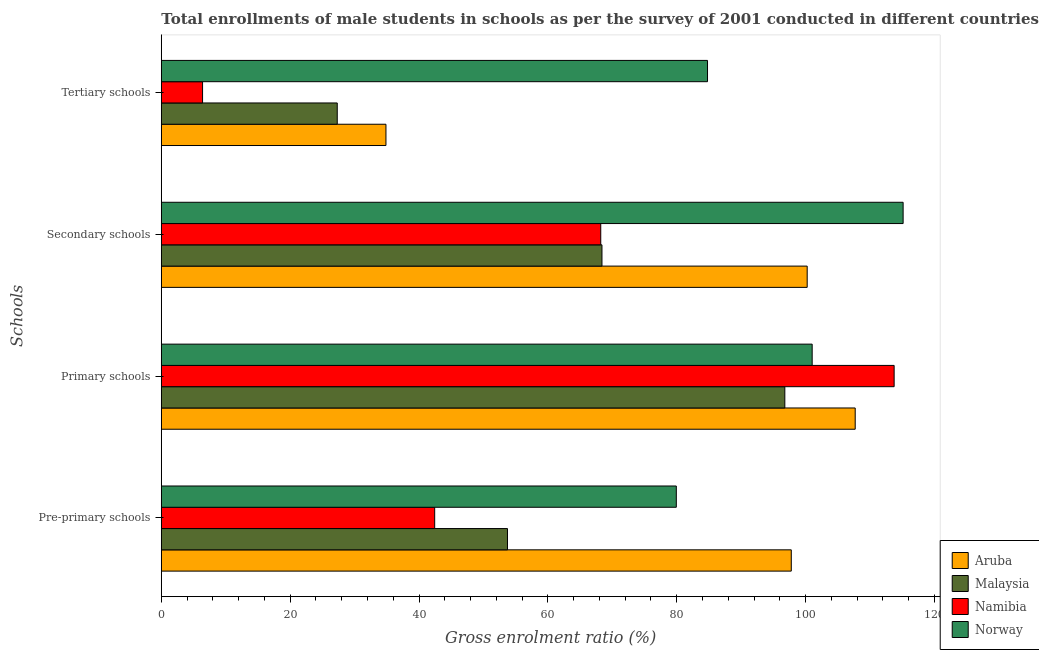Are the number of bars per tick equal to the number of legend labels?
Give a very brief answer. Yes. Are the number of bars on each tick of the Y-axis equal?
Provide a succinct answer. Yes. How many bars are there on the 2nd tick from the bottom?
Your answer should be compact. 4. What is the label of the 1st group of bars from the top?
Provide a short and direct response. Tertiary schools. What is the gross enrolment ratio(male) in pre-primary schools in Malaysia?
Your answer should be compact. 53.73. Across all countries, what is the maximum gross enrolment ratio(male) in pre-primary schools?
Your answer should be compact. 97.77. Across all countries, what is the minimum gross enrolment ratio(male) in primary schools?
Keep it short and to the point. 96.77. In which country was the gross enrolment ratio(male) in tertiary schools maximum?
Give a very brief answer. Norway. In which country was the gross enrolment ratio(male) in tertiary schools minimum?
Offer a terse response. Namibia. What is the total gross enrolment ratio(male) in tertiary schools in the graph?
Ensure brevity in your answer.  153.35. What is the difference between the gross enrolment ratio(male) in secondary schools in Norway and that in Malaysia?
Your answer should be very brief. 46.74. What is the difference between the gross enrolment ratio(male) in secondary schools in Aruba and the gross enrolment ratio(male) in tertiary schools in Norway?
Make the answer very short. 15.47. What is the average gross enrolment ratio(male) in tertiary schools per country?
Make the answer very short. 38.34. What is the difference between the gross enrolment ratio(male) in tertiary schools and gross enrolment ratio(male) in primary schools in Norway?
Make the answer very short. -16.24. In how many countries, is the gross enrolment ratio(male) in pre-primary schools greater than 52 %?
Ensure brevity in your answer.  3. What is the ratio of the gross enrolment ratio(male) in pre-primary schools in Namibia to that in Malaysia?
Provide a succinct answer. 0.79. Is the gross enrolment ratio(male) in primary schools in Malaysia less than that in Norway?
Offer a terse response. Yes. What is the difference between the highest and the second highest gross enrolment ratio(male) in pre-primary schools?
Give a very brief answer. 17.84. What is the difference between the highest and the lowest gross enrolment ratio(male) in primary schools?
Make the answer very short. 16.97. Is it the case that in every country, the sum of the gross enrolment ratio(male) in secondary schools and gross enrolment ratio(male) in tertiary schools is greater than the sum of gross enrolment ratio(male) in primary schools and gross enrolment ratio(male) in pre-primary schools?
Ensure brevity in your answer.  No. What does the 2nd bar from the top in Pre-primary schools represents?
Provide a short and direct response. Namibia. What does the 2nd bar from the bottom in Secondary schools represents?
Provide a short and direct response. Malaysia. How many bars are there?
Offer a very short reply. 16. Are all the bars in the graph horizontal?
Your answer should be compact. Yes. How many countries are there in the graph?
Provide a succinct answer. 4. Are the values on the major ticks of X-axis written in scientific E-notation?
Keep it short and to the point. No. Does the graph contain grids?
Your answer should be very brief. No. How are the legend labels stacked?
Offer a terse response. Vertical. What is the title of the graph?
Offer a terse response. Total enrollments of male students in schools as per the survey of 2001 conducted in different countries. What is the label or title of the X-axis?
Offer a terse response. Gross enrolment ratio (%). What is the label or title of the Y-axis?
Offer a very short reply. Schools. What is the Gross enrolment ratio (%) of Aruba in Pre-primary schools?
Make the answer very short. 97.77. What is the Gross enrolment ratio (%) of Malaysia in Pre-primary schools?
Your answer should be very brief. 53.73. What is the Gross enrolment ratio (%) in Namibia in Pre-primary schools?
Your response must be concise. 42.43. What is the Gross enrolment ratio (%) of Norway in Pre-primary schools?
Provide a succinct answer. 79.93. What is the Gross enrolment ratio (%) in Aruba in Primary schools?
Offer a terse response. 107.7. What is the Gross enrolment ratio (%) of Malaysia in Primary schools?
Offer a very short reply. 96.77. What is the Gross enrolment ratio (%) in Namibia in Primary schools?
Your answer should be very brief. 113.74. What is the Gross enrolment ratio (%) of Norway in Primary schools?
Offer a terse response. 101.02. What is the Gross enrolment ratio (%) in Aruba in Secondary schools?
Make the answer very short. 100.24. What is the Gross enrolment ratio (%) of Malaysia in Secondary schools?
Offer a terse response. 68.39. What is the Gross enrolment ratio (%) in Namibia in Secondary schools?
Keep it short and to the point. 68.2. What is the Gross enrolment ratio (%) of Norway in Secondary schools?
Make the answer very short. 115.13. What is the Gross enrolment ratio (%) in Aruba in Tertiary schools?
Provide a succinct answer. 34.87. What is the Gross enrolment ratio (%) in Malaysia in Tertiary schools?
Keep it short and to the point. 27.31. What is the Gross enrolment ratio (%) in Namibia in Tertiary schools?
Provide a short and direct response. 6.4. What is the Gross enrolment ratio (%) in Norway in Tertiary schools?
Provide a succinct answer. 84.77. Across all Schools, what is the maximum Gross enrolment ratio (%) in Aruba?
Make the answer very short. 107.7. Across all Schools, what is the maximum Gross enrolment ratio (%) of Malaysia?
Keep it short and to the point. 96.77. Across all Schools, what is the maximum Gross enrolment ratio (%) in Namibia?
Keep it short and to the point. 113.74. Across all Schools, what is the maximum Gross enrolment ratio (%) of Norway?
Your answer should be very brief. 115.13. Across all Schools, what is the minimum Gross enrolment ratio (%) in Aruba?
Give a very brief answer. 34.87. Across all Schools, what is the minimum Gross enrolment ratio (%) of Malaysia?
Provide a succinct answer. 27.31. Across all Schools, what is the minimum Gross enrolment ratio (%) of Namibia?
Your answer should be very brief. 6.4. Across all Schools, what is the minimum Gross enrolment ratio (%) in Norway?
Offer a terse response. 79.93. What is the total Gross enrolment ratio (%) of Aruba in the graph?
Offer a terse response. 340.58. What is the total Gross enrolment ratio (%) of Malaysia in the graph?
Make the answer very short. 246.2. What is the total Gross enrolment ratio (%) in Namibia in the graph?
Your answer should be compact. 230.77. What is the total Gross enrolment ratio (%) of Norway in the graph?
Provide a succinct answer. 380.85. What is the difference between the Gross enrolment ratio (%) in Aruba in Pre-primary schools and that in Primary schools?
Keep it short and to the point. -9.92. What is the difference between the Gross enrolment ratio (%) in Malaysia in Pre-primary schools and that in Primary schools?
Provide a short and direct response. -43.04. What is the difference between the Gross enrolment ratio (%) of Namibia in Pre-primary schools and that in Primary schools?
Ensure brevity in your answer.  -71.31. What is the difference between the Gross enrolment ratio (%) of Norway in Pre-primary schools and that in Primary schools?
Make the answer very short. -21.09. What is the difference between the Gross enrolment ratio (%) in Aruba in Pre-primary schools and that in Secondary schools?
Offer a terse response. -2.47. What is the difference between the Gross enrolment ratio (%) of Malaysia in Pre-primary schools and that in Secondary schools?
Your answer should be very brief. -14.66. What is the difference between the Gross enrolment ratio (%) in Namibia in Pre-primary schools and that in Secondary schools?
Offer a very short reply. -25.77. What is the difference between the Gross enrolment ratio (%) of Norway in Pre-primary schools and that in Secondary schools?
Give a very brief answer. -35.2. What is the difference between the Gross enrolment ratio (%) in Aruba in Pre-primary schools and that in Tertiary schools?
Keep it short and to the point. 62.91. What is the difference between the Gross enrolment ratio (%) in Malaysia in Pre-primary schools and that in Tertiary schools?
Keep it short and to the point. 26.42. What is the difference between the Gross enrolment ratio (%) in Namibia in Pre-primary schools and that in Tertiary schools?
Your answer should be compact. 36.03. What is the difference between the Gross enrolment ratio (%) in Norway in Pre-primary schools and that in Tertiary schools?
Offer a terse response. -4.84. What is the difference between the Gross enrolment ratio (%) of Aruba in Primary schools and that in Secondary schools?
Give a very brief answer. 7.45. What is the difference between the Gross enrolment ratio (%) of Malaysia in Primary schools and that in Secondary schools?
Your answer should be very brief. 28.38. What is the difference between the Gross enrolment ratio (%) of Namibia in Primary schools and that in Secondary schools?
Keep it short and to the point. 45.53. What is the difference between the Gross enrolment ratio (%) in Norway in Primary schools and that in Secondary schools?
Your answer should be compact. -14.12. What is the difference between the Gross enrolment ratio (%) of Aruba in Primary schools and that in Tertiary schools?
Keep it short and to the point. 72.83. What is the difference between the Gross enrolment ratio (%) in Malaysia in Primary schools and that in Tertiary schools?
Provide a succinct answer. 69.47. What is the difference between the Gross enrolment ratio (%) of Namibia in Primary schools and that in Tertiary schools?
Provide a short and direct response. 107.34. What is the difference between the Gross enrolment ratio (%) in Norway in Primary schools and that in Tertiary schools?
Provide a succinct answer. 16.24. What is the difference between the Gross enrolment ratio (%) of Aruba in Secondary schools and that in Tertiary schools?
Offer a terse response. 65.38. What is the difference between the Gross enrolment ratio (%) in Malaysia in Secondary schools and that in Tertiary schools?
Provide a short and direct response. 41.09. What is the difference between the Gross enrolment ratio (%) in Namibia in Secondary schools and that in Tertiary schools?
Give a very brief answer. 61.8. What is the difference between the Gross enrolment ratio (%) in Norway in Secondary schools and that in Tertiary schools?
Your response must be concise. 30.36. What is the difference between the Gross enrolment ratio (%) of Aruba in Pre-primary schools and the Gross enrolment ratio (%) of Malaysia in Primary schools?
Provide a succinct answer. 1. What is the difference between the Gross enrolment ratio (%) in Aruba in Pre-primary schools and the Gross enrolment ratio (%) in Namibia in Primary schools?
Your answer should be very brief. -15.96. What is the difference between the Gross enrolment ratio (%) in Aruba in Pre-primary schools and the Gross enrolment ratio (%) in Norway in Primary schools?
Offer a terse response. -3.24. What is the difference between the Gross enrolment ratio (%) in Malaysia in Pre-primary schools and the Gross enrolment ratio (%) in Namibia in Primary schools?
Offer a terse response. -60.01. What is the difference between the Gross enrolment ratio (%) in Malaysia in Pre-primary schools and the Gross enrolment ratio (%) in Norway in Primary schools?
Give a very brief answer. -47.29. What is the difference between the Gross enrolment ratio (%) of Namibia in Pre-primary schools and the Gross enrolment ratio (%) of Norway in Primary schools?
Give a very brief answer. -58.59. What is the difference between the Gross enrolment ratio (%) in Aruba in Pre-primary schools and the Gross enrolment ratio (%) in Malaysia in Secondary schools?
Your response must be concise. 29.38. What is the difference between the Gross enrolment ratio (%) of Aruba in Pre-primary schools and the Gross enrolment ratio (%) of Namibia in Secondary schools?
Ensure brevity in your answer.  29.57. What is the difference between the Gross enrolment ratio (%) of Aruba in Pre-primary schools and the Gross enrolment ratio (%) of Norway in Secondary schools?
Your answer should be compact. -17.36. What is the difference between the Gross enrolment ratio (%) of Malaysia in Pre-primary schools and the Gross enrolment ratio (%) of Namibia in Secondary schools?
Give a very brief answer. -14.48. What is the difference between the Gross enrolment ratio (%) in Malaysia in Pre-primary schools and the Gross enrolment ratio (%) in Norway in Secondary schools?
Offer a very short reply. -61.41. What is the difference between the Gross enrolment ratio (%) of Namibia in Pre-primary schools and the Gross enrolment ratio (%) of Norway in Secondary schools?
Ensure brevity in your answer.  -72.7. What is the difference between the Gross enrolment ratio (%) in Aruba in Pre-primary schools and the Gross enrolment ratio (%) in Malaysia in Tertiary schools?
Your answer should be very brief. 70.47. What is the difference between the Gross enrolment ratio (%) of Aruba in Pre-primary schools and the Gross enrolment ratio (%) of Namibia in Tertiary schools?
Your answer should be compact. 91.37. What is the difference between the Gross enrolment ratio (%) in Aruba in Pre-primary schools and the Gross enrolment ratio (%) in Norway in Tertiary schools?
Offer a very short reply. 13. What is the difference between the Gross enrolment ratio (%) in Malaysia in Pre-primary schools and the Gross enrolment ratio (%) in Namibia in Tertiary schools?
Offer a terse response. 47.33. What is the difference between the Gross enrolment ratio (%) in Malaysia in Pre-primary schools and the Gross enrolment ratio (%) in Norway in Tertiary schools?
Offer a terse response. -31.05. What is the difference between the Gross enrolment ratio (%) in Namibia in Pre-primary schools and the Gross enrolment ratio (%) in Norway in Tertiary schools?
Your response must be concise. -42.34. What is the difference between the Gross enrolment ratio (%) in Aruba in Primary schools and the Gross enrolment ratio (%) in Malaysia in Secondary schools?
Your answer should be compact. 39.3. What is the difference between the Gross enrolment ratio (%) in Aruba in Primary schools and the Gross enrolment ratio (%) in Namibia in Secondary schools?
Offer a very short reply. 39.49. What is the difference between the Gross enrolment ratio (%) in Aruba in Primary schools and the Gross enrolment ratio (%) in Norway in Secondary schools?
Offer a terse response. -7.44. What is the difference between the Gross enrolment ratio (%) in Malaysia in Primary schools and the Gross enrolment ratio (%) in Namibia in Secondary schools?
Give a very brief answer. 28.57. What is the difference between the Gross enrolment ratio (%) of Malaysia in Primary schools and the Gross enrolment ratio (%) of Norway in Secondary schools?
Provide a succinct answer. -18.36. What is the difference between the Gross enrolment ratio (%) of Namibia in Primary schools and the Gross enrolment ratio (%) of Norway in Secondary schools?
Your response must be concise. -1.39. What is the difference between the Gross enrolment ratio (%) of Aruba in Primary schools and the Gross enrolment ratio (%) of Malaysia in Tertiary schools?
Provide a short and direct response. 80.39. What is the difference between the Gross enrolment ratio (%) of Aruba in Primary schools and the Gross enrolment ratio (%) of Namibia in Tertiary schools?
Keep it short and to the point. 101.29. What is the difference between the Gross enrolment ratio (%) of Aruba in Primary schools and the Gross enrolment ratio (%) of Norway in Tertiary schools?
Offer a terse response. 22.92. What is the difference between the Gross enrolment ratio (%) of Malaysia in Primary schools and the Gross enrolment ratio (%) of Namibia in Tertiary schools?
Offer a terse response. 90.37. What is the difference between the Gross enrolment ratio (%) of Malaysia in Primary schools and the Gross enrolment ratio (%) of Norway in Tertiary schools?
Your response must be concise. 12. What is the difference between the Gross enrolment ratio (%) of Namibia in Primary schools and the Gross enrolment ratio (%) of Norway in Tertiary schools?
Provide a succinct answer. 28.97. What is the difference between the Gross enrolment ratio (%) of Aruba in Secondary schools and the Gross enrolment ratio (%) of Malaysia in Tertiary schools?
Offer a very short reply. 72.94. What is the difference between the Gross enrolment ratio (%) of Aruba in Secondary schools and the Gross enrolment ratio (%) of Namibia in Tertiary schools?
Provide a short and direct response. 93.84. What is the difference between the Gross enrolment ratio (%) of Aruba in Secondary schools and the Gross enrolment ratio (%) of Norway in Tertiary schools?
Give a very brief answer. 15.47. What is the difference between the Gross enrolment ratio (%) of Malaysia in Secondary schools and the Gross enrolment ratio (%) of Namibia in Tertiary schools?
Your response must be concise. 61.99. What is the difference between the Gross enrolment ratio (%) in Malaysia in Secondary schools and the Gross enrolment ratio (%) in Norway in Tertiary schools?
Ensure brevity in your answer.  -16.38. What is the difference between the Gross enrolment ratio (%) of Namibia in Secondary schools and the Gross enrolment ratio (%) of Norway in Tertiary schools?
Your answer should be compact. -16.57. What is the average Gross enrolment ratio (%) in Aruba per Schools?
Your response must be concise. 85.15. What is the average Gross enrolment ratio (%) of Malaysia per Schools?
Offer a very short reply. 61.55. What is the average Gross enrolment ratio (%) of Namibia per Schools?
Offer a terse response. 57.69. What is the average Gross enrolment ratio (%) in Norway per Schools?
Make the answer very short. 95.21. What is the difference between the Gross enrolment ratio (%) in Aruba and Gross enrolment ratio (%) in Malaysia in Pre-primary schools?
Make the answer very short. 44.05. What is the difference between the Gross enrolment ratio (%) of Aruba and Gross enrolment ratio (%) of Namibia in Pre-primary schools?
Your response must be concise. 55.35. What is the difference between the Gross enrolment ratio (%) in Aruba and Gross enrolment ratio (%) in Norway in Pre-primary schools?
Give a very brief answer. 17.84. What is the difference between the Gross enrolment ratio (%) of Malaysia and Gross enrolment ratio (%) of Namibia in Pre-primary schools?
Make the answer very short. 11.3. What is the difference between the Gross enrolment ratio (%) in Malaysia and Gross enrolment ratio (%) in Norway in Pre-primary schools?
Provide a short and direct response. -26.2. What is the difference between the Gross enrolment ratio (%) in Namibia and Gross enrolment ratio (%) in Norway in Pre-primary schools?
Ensure brevity in your answer.  -37.5. What is the difference between the Gross enrolment ratio (%) of Aruba and Gross enrolment ratio (%) of Malaysia in Primary schools?
Your answer should be very brief. 10.92. What is the difference between the Gross enrolment ratio (%) of Aruba and Gross enrolment ratio (%) of Namibia in Primary schools?
Offer a very short reply. -6.04. What is the difference between the Gross enrolment ratio (%) in Aruba and Gross enrolment ratio (%) in Norway in Primary schools?
Your response must be concise. 6.68. What is the difference between the Gross enrolment ratio (%) in Malaysia and Gross enrolment ratio (%) in Namibia in Primary schools?
Offer a very short reply. -16.97. What is the difference between the Gross enrolment ratio (%) in Malaysia and Gross enrolment ratio (%) in Norway in Primary schools?
Make the answer very short. -4.24. What is the difference between the Gross enrolment ratio (%) of Namibia and Gross enrolment ratio (%) of Norway in Primary schools?
Keep it short and to the point. 12.72. What is the difference between the Gross enrolment ratio (%) in Aruba and Gross enrolment ratio (%) in Malaysia in Secondary schools?
Your answer should be compact. 31.85. What is the difference between the Gross enrolment ratio (%) of Aruba and Gross enrolment ratio (%) of Namibia in Secondary schools?
Give a very brief answer. 32.04. What is the difference between the Gross enrolment ratio (%) of Aruba and Gross enrolment ratio (%) of Norway in Secondary schools?
Offer a very short reply. -14.89. What is the difference between the Gross enrolment ratio (%) in Malaysia and Gross enrolment ratio (%) in Namibia in Secondary schools?
Keep it short and to the point. 0.19. What is the difference between the Gross enrolment ratio (%) in Malaysia and Gross enrolment ratio (%) in Norway in Secondary schools?
Offer a very short reply. -46.74. What is the difference between the Gross enrolment ratio (%) of Namibia and Gross enrolment ratio (%) of Norway in Secondary schools?
Offer a terse response. -46.93. What is the difference between the Gross enrolment ratio (%) in Aruba and Gross enrolment ratio (%) in Malaysia in Tertiary schools?
Provide a succinct answer. 7.56. What is the difference between the Gross enrolment ratio (%) in Aruba and Gross enrolment ratio (%) in Namibia in Tertiary schools?
Keep it short and to the point. 28.46. What is the difference between the Gross enrolment ratio (%) in Aruba and Gross enrolment ratio (%) in Norway in Tertiary schools?
Your response must be concise. -49.91. What is the difference between the Gross enrolment ratio (%) of Malaysia and Gross enrolment ratio (%) of Namibia in Tertiary schools?
Provide a succinct answer. 20.91. What is the difference between the Gross enrolment ratio (%) of Malaysia and Gross enrolment ratio (%) of Norway in Tertiary schools?
Offer a terse response. -57.47. What is the difference between the Gross enrolment ratio (%) of Namibia and Gross enrolment ratio (%) of Norway in Tertiary schools?
Your answer should be very brief. -78.37. What is the ratio of the Gross enrolment ratio (%) of Aruba in Pre-primary schools to that in Primary schools?
Make the answer very short. 0.91. What is the ratio of the Gross enrolment ratio (%) in Malaysia in Pre-primary schools to that in Primary schools?
Your answer should be compact. 0.56. What is the ratio of the Gross enrolment ratio (%) in Namibia in Pre-primary schools to that in Primary schools?
Give a very brief answer. 0.37. What is the ratio of the Gross enrolment ratio (%) in Norway in Pre-primary schools to that in Primary schools?
Your answer should be very brief. 0.79. What is the ratio of the Gross enrolment ratio (%) in Aruba in Pre-primary schools to that in Secondary schools?
Your answer should be very brief. 0.98. What is the ratio of the Gross enrolment ratio (%) in Malaysia in Pre-primary schools to that in Secondary schools?
Offer a terse response. 0.79. What is the ratio of the Gross enrolment ratio (%) of Namibia in Pre-primary schools to that in Secondary schools?
Provide a succinct answer. 0.62. What is the ratio of the Gross enrolment ratio (%) in Norway in Pre-primary schools to that in Secondary schools?
Keep it short and to the point. 0.69. What is the ratio of the Gross enrolment ratio (%) in Aruba in Pre-primary schools to that in Tertiary schools?
Ensure brevity in your answer.  2.8. What is the ratio of the Gross enrolment ratio (%) of Malaysia in Pre-primary schools to that in Tertiary schools?
Ensure brevity in your answer.  1.97. What is the ratio of the Gross enrolment ratio (%) in Namibia in Pre-primary schools to that in Tertiary schools?
Your answer should be compact. 6.63. What is the ratio of the Gross enrolment ratio (%) in Norway in Pre-primary schools to that in Tertiary schools?
Offer a terse response. 0.94. What is the ratio of the Gross enrolment ratio (%) in Aruba in Primary schools to that in Secondary schools?
Ensure brevity in your answer.  1.07. What is the ratio of the Gross enrolment ratio (%) of Malaysia in Primary schools to that in Secondary schools?
Offer a terse response. 1.42. What is the ratio of the Gross enrolment ratio (%) of Namibia in Primary schools to that in Secondary schools?
Your answer should be compact. 1.67. What is the ratio of the Gross enrolment ratio (%) of Norway in Primary schools to that in Secondary schools?
Ensure brevity in your answer.  0.88. What is the ratio of the Gross enrolment ratio (%) of Aruba in Primary schools to that in Tertiary schools?
Make the answer very short. 3.09. What is the ratio of the Gross enrolment ratio (%) of Malaysia in Primary schools to that in Tertiary schools?
Ensure brevity in your answer.  3.54. What is the ratio of the Gross enrolment ratio (%) of Namibia in Primary schools to that in Tertiary schools?
Offer a very short reply. 17.77. What is the ratio of the Gross enrolment ratio (%) of Norway in Primary schools to that in Tertiary schools?
Keep it short and to the point. 1.19. What is the ratio of the Gross enrolment ratio (%) of Aruba in Secondary schools to that in Tertiary schools?
Your answer should be very brief. 2.88. What is the ratio of the Gross enrolment ratio (%) of Malaysia in Secondary schools to that in Tertiary schools?
Offer a very short reply. 2.5. What is the ratio of the Gross enrolment ratio (%) in Namibia in Secondary schools to that in Tertiary schools?
Offer a terse response. 10.65. What is the ratio of the Gross enrolment ratio (%) in Norway in Secondary schools to that in Tertiary schools?
Ensure brevity in your answer.  1.36. What is the difference between the highest and the second highest Gross enrolment ratio (%) in Aruba?
Your answer should be very brief. 7.45. What is the difference between the highest and the second highest Gross enrolment ratio (%) of Malaysia?
Offer a terse response. 28.38. What is the difference between the highest and the second highest Gross enrolment ratio (%) of Namibia?
Keep it short and to the point. 45.53. What is the difference between the highest and the second highest Gross enrolment ratio (%) in Norway?
Provide a succinct answer. 14.12. What is the difference between the highest and the lowest Gross enrolment ratio (%) in Aruba?
Offer a very short reply. 72.83. What is the difference between the highest and the lowest Gross enrolment ratio (%) in Malaysia?
Offer a terse response. 69.47. What is the difference between the highest and the lowest Gross enrolment ratio (%) in Namibia?
Offer a terse response. 107.34. What is the difference between the highest and the lowest Gross enrolment ratio (%) of Norway?
Give a very brief answer. 35.2. 